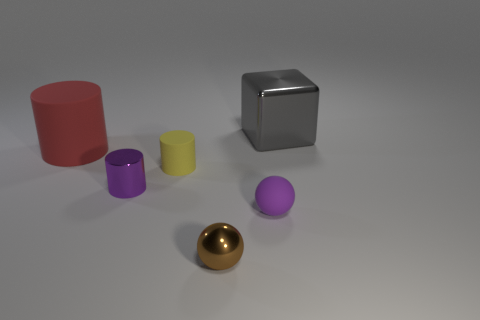What is the shape of the tiny rubber object that is the same color as the metal cylinder?
Make the answer very short. Sphere. There is a rubber object right of the tiny brown ball; is it the same shape as the thing that is behind the large rubber thing?
Keep it short and to the point. No. Are there the same number of gray cubes to the right of the small brown metal object and red rubber spheres?
Your answer should be very brief. No. There is a matte cylinder that is in front of the red rubber cylinder; are there any tiny purple matte balls that are to the left of it?
Provide a succinct answer. No. Is there anything else of the same color as the large shiny object?
Provide a short and direct response. No. Is the small purple object to the right of the brown ball made of the same material as the red thing?
Keep it short and to the point. Yes. Are there an equal number of things that are behind the purple shiny object and tiny brown balls on the right side of the small purple rubber ball?
Keep it short and to the point. No. What size is the metallic object that is right of the rubber object that is in front of the yellow rubber cylinder?
Make the answer very short. Large. The cylinder that is both left of the small yellow matte thing and to the right of the large red matte cylinder is made of what material?
Your response must be concise. Metal. What number of other objects are the same size as the brown sphere?
Make the answer very short. 3. 